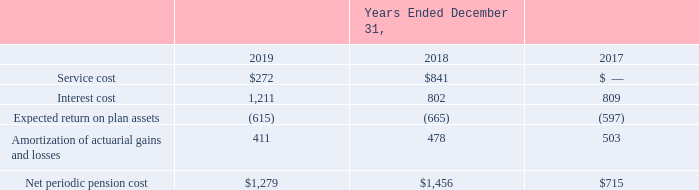ADVANCED ENERGY INDUSTRIES, INC. NOTES TO CONSOLIDATED FINANCIAL STATEMENTS – (continued) (in thousands, except per share amounts)
The information provided below includes one pension plan which is part of discontinued operations. As such, all related liabilities and expenses are reported in discontinued operations in the Company’s Consolidated Balance Sheets and Consolidated Statements of Operations for all periods presented.
The components of net periodic pension benefit cost recognized in our Consolidated Statements of Operations for the periods presented are as follows:
What was service cost in 2019?
Answer scale should be: thousand. $272. What was interest cost in 2018?
Answer scale should be: thousand. 802. What was the Expected return on plan assets in 2017?
Answer scale should be: thousand. (597). What was the change in the net periodic pension cost between 2018 and 2019?
Answer scale should be: thousand. $1,279-$1,456
Answer: -177. What was the change in Amortization of actuarial gains and losses between 2017 and 2018?
Answer scale should be: thousand. 478-503
Answer: -25. What was the percentage change in Interest cost between 2018 and 2019?
Answer scale should be: percent. (1,211-802)/802
Answer: 51. 